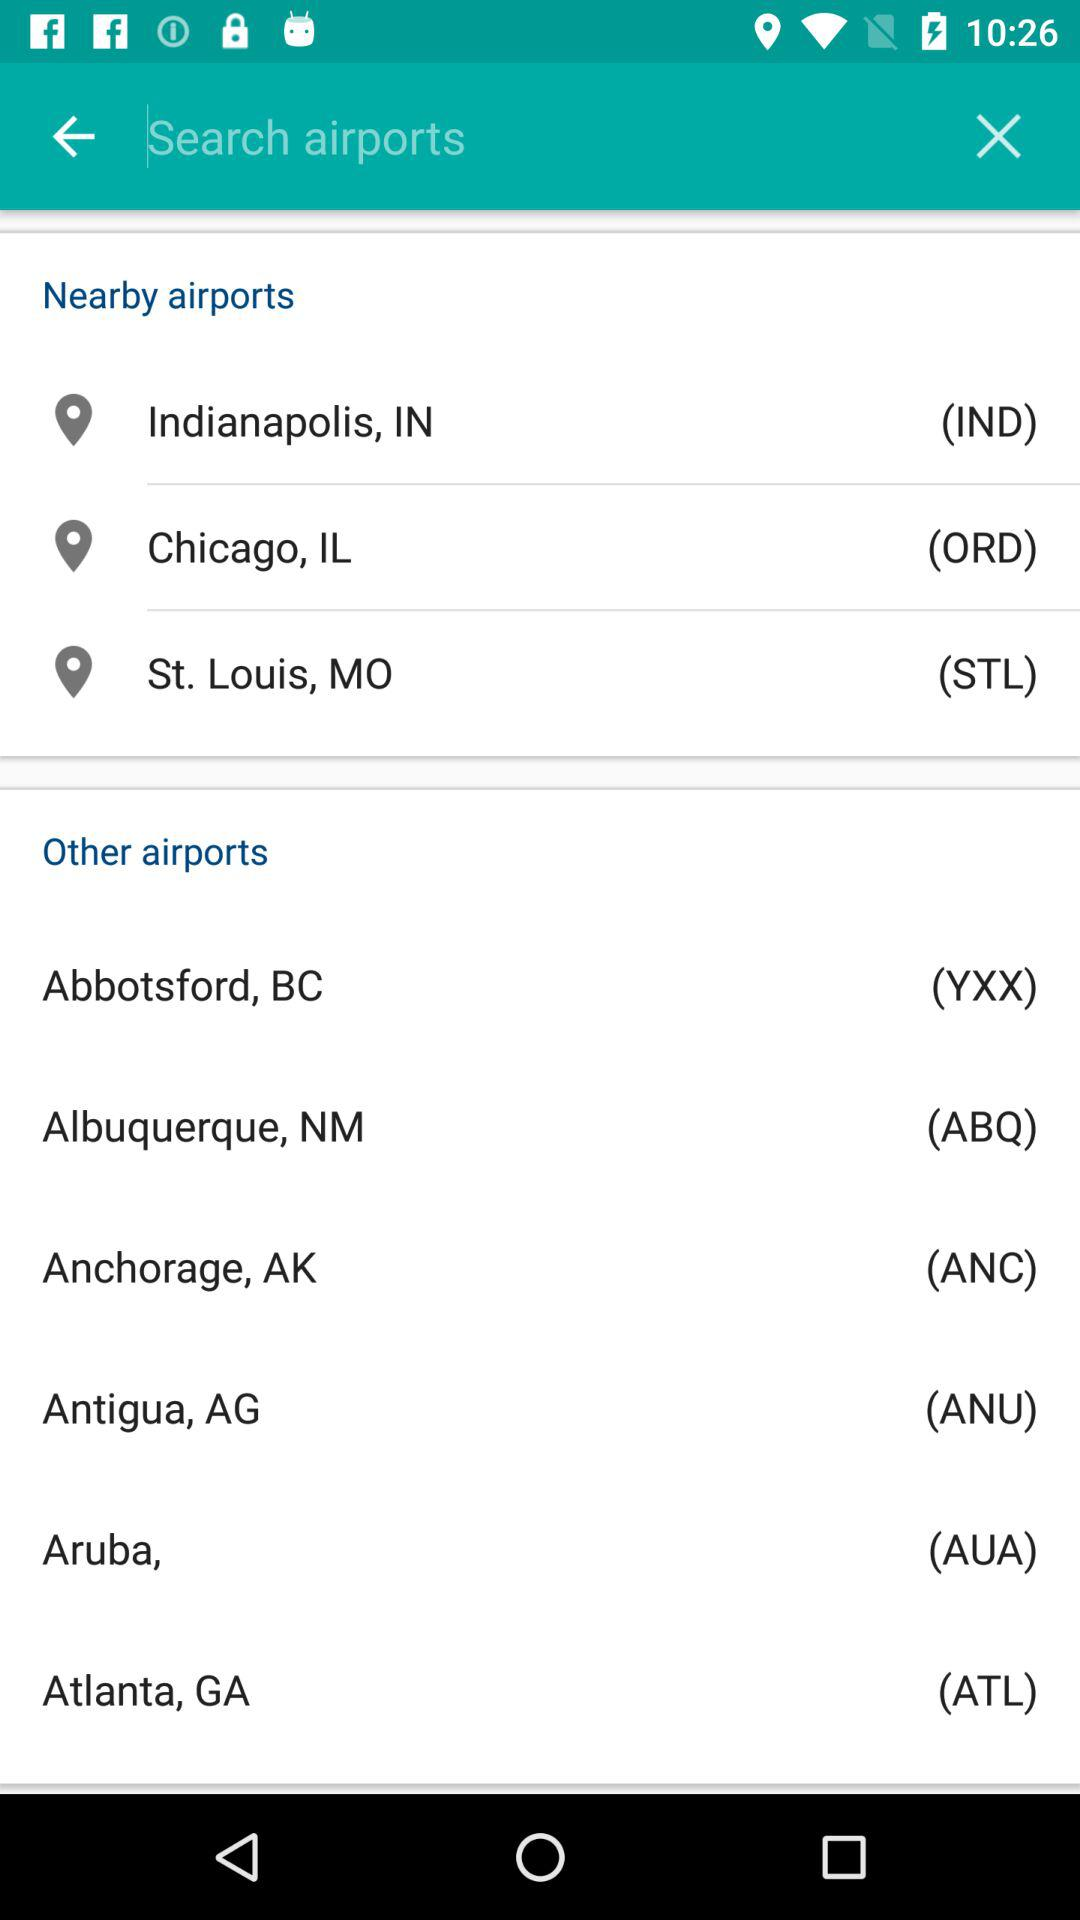What are the nearby airports? The nearby airports are Indianapolis, IN, Chicago, IL and St. Louis, MO. 